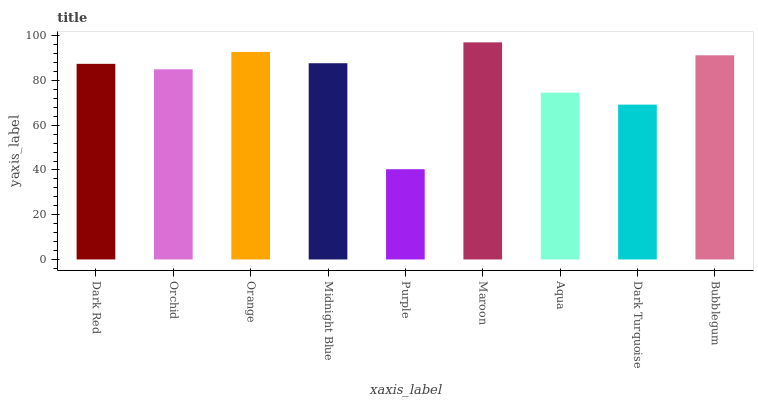Is Orchid the minimum?
Answer yes or no. No. Is Orchid the maximum?
Answer yes or no. No. Is Dark Red greater than Orchid?
Answer yes or no. Yes. Is Orchid less than Dark Red?
Answer yes or no. Yes. Is Orchid greater than Dark Red?
Answer yes or no. No. Is Dark Red less than Orchid?
Answer yes or no. No. Is Dark Red the high median?
Answer yes or no. Yes. Is Dark Red the low median?
Answer yes or no. Yes. Is Orchid the high median?
Answer yes or no. No. Is Bubblegum the low median?
Answer yes or no. No. 